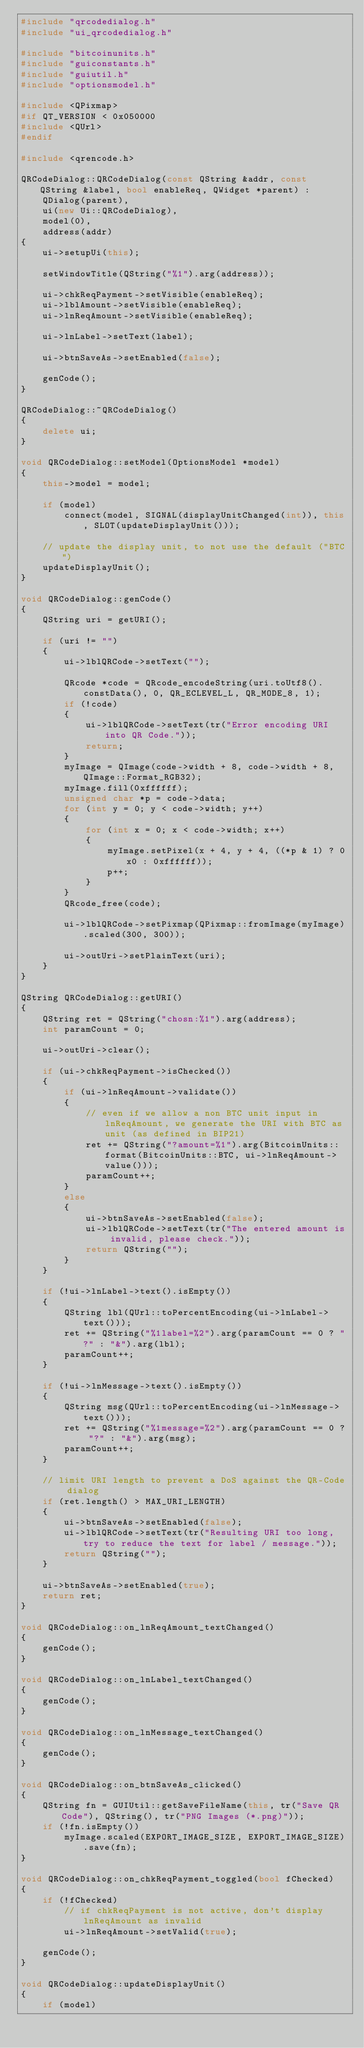<code> <loc_0><loc_0><loc_500><loc_500><_C++_>#include "qrcodedialog.h"
#include "ui_qrcodedialog.h"

#include "bitcoinunits.h"
#include "guiconstants.h"
#include "guiutil.h"
#include "optionsmodel.h"

#include <QPixmap>
#if QT_VERSION < 0x050000
#include <QUrl>
#endif

#include <qrencode.h>

QRCodeDialog::QRCodeDialog(const QString &addr, const QString &label, bool enableReq, QWidget *parent) :
    QDialog(parent),
    ui(new Ui::QRCodeDialog),
    model(0),
    address(addr)
{
    ui->setupUi(this);

    setWindowTitle(QString("%1").arg(address));

    ui->chkReqPayment->setVisible(enableReq);
    ui->lblAmount->setVisible(enableReq);
    ui->lnReqAmount->setVisible(enableReq);

    ui->lnLabel->setText(label);

    ui->btnSaveAs->setEnabled(false);

    genCode();
}

QRCodeDialog::~QRCodeDialog()
{
    delete ui;
}

void QRCodeDialog::setModel(OptionsModel *model)
{
    this->model = model;

    if (model)
        connect(model, SIGNAL(displayUnitChanged(int)), this, SLOT(updateDisplayUnit()));

    // update the display unit, to not use the default ("BTC")
    updateDisplayUnit();
}

void QRCodeDialog::genCode()
{
    QString uri = getURI();

    if (uri != "")
    {
        ui->lblQRCode->setText("");

        QRcode *code = QRcode_encodeString(uri.toUtf8().constData(), 0, QR_ECLEVEL_L, QR_MODE_8, 1);
        if (!code)
        {
            ui->lblQRCode->setText(tr("Error encoding URI into QR Code."));
            return;
        }
        myImage = QImage(code->width + 8, code->width + 8, QImage::Format_RGB32);
        myImage.fill(0xffffff);
        unsigned char *p = code->data;
        for (int y = 0; y < code->width; y++)
        {
            for (int x = 0; x < code->width; x++)
            {
                myImage.setPixel(x + 4, y + 4, ((*p & 1) ? 0x0 : 0xffffff));
                p++;
            }
        }
        QRcode_free(code);

        ui->lblQRCode->setPixmap(QPixmap::fromImage(myImage).scaled(300, 300));

        ui->outUri->setPlainText(uri);
    }
}

QString QRCodeDialog::getURI()
{
    QString ret = QString("chosn:%1").arg(address);
    int paramCount = 0;

    ui->outUri->clear();

    if (ui->chkReqPayment->isChecked())
    {
        if (ui->lnReqAmount->validate())
        {
            // even if we allow a non BTC unit input in lnReqAmount, we generate the URI with BTC as unit (as defined in BIP21)
            ret += QString("?amount=%1").arg(BitcoinUnits::format(BitcoinUnits::BTC, ui->lnReqAmount->value()));
            paramCount++;
        }
        else
        {
            ui->btnSaveAs->setEnabled(false);
            ui->lblQRCode->setText(tr("The entered amount is invalid, please check."));
            return QString("");
        }
    }

    if (!ui->lnLabel->text().isEmpty())
    {
        QString lbl(QUrl::toPercentEncoding(ui->lnLabel->text()));
        ret += QString("%1label=%2").arg(paramCount == 0 ? "?" : "&").arg(lbl);
        paramCount++;
    }

    if (!ui->lnMessage->text().isEmpty())
    {
        QString msg(QUrl::toPercentEncoding(ui->lnMessage->text()));
        ret += QString("%1message=%2").arg(paramCount == 0 ? "?" : "&").arg(msg);
        paramCount++;
    }

    // limit URI length to prevent a DoS against the QR-Code dialog
    if (ret.length() > MAX_URI_LENGTH)
    {
        ui->btnSaveAs->setEnabled(false);
        ui->lblQRCode->setText(tr("Resulting URI too long, try to reduce the text for label / message."));
        return QString("");
    }

    ui->btnSaveAs->setEnabled(true);
    return ret;
}

void QRCodeDialog::on_lnReqAmount_textChanged()
{
    genCode();
}

void QRCodeDialog::on_lnLabel_textChanged()
{
    genCode();
}

void QRCodeDialog::on_lnMessage_textChanged()
{
    genCode();
}

void QRCodeDialog::on_btnSaveAs_clicked()
{
    QString fn = GUIUtil::getSaveFileName(this, tr("Save QR Code"), QString(), tr("PNG Images (*.png)"));
    if (!fn.isEmpty())
        myImage.scaled(EXPORT_IMAGE_SIZE, EXPORT_IMAGE_SIZE).save(fn);
}

void QRCodeDialog::on_chkReqPayment_toggled(bool fChecked)
{
    if (!fChecked)
        // if chkReqPayment is not active, don't display lnReqAmount as invalid
        ui->lnReqAmount->setValid(true);

    genCode();
}

void QRCodeDialog::updateDisplayUnit()
{
    if (model)</code> 